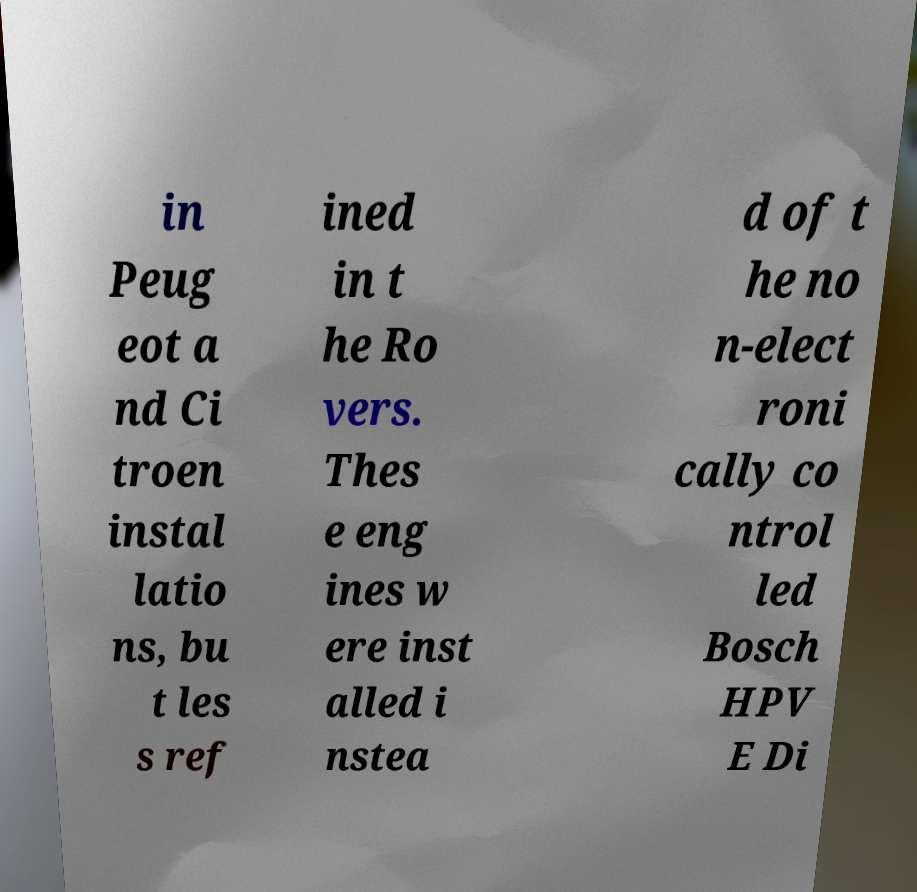Please read and relay the text visible in this image. What does it say? in Peug eot a nd Ci troen instal latio ns, bu t les s ref ined in t he Ro vers. Thes e eng ines w ere inst alled i nstea d of t he no n-elect roni cally co ntrol led Bosch HPV E Di 